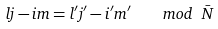<formula> <loc_0><loc_0><loc_500><loc_500>l j - i m = l ^ { \prime } j ^ { \prime } - i ^ { \prime } m ^ { \prime } \quad m o d \ \bar { N }</formula> 